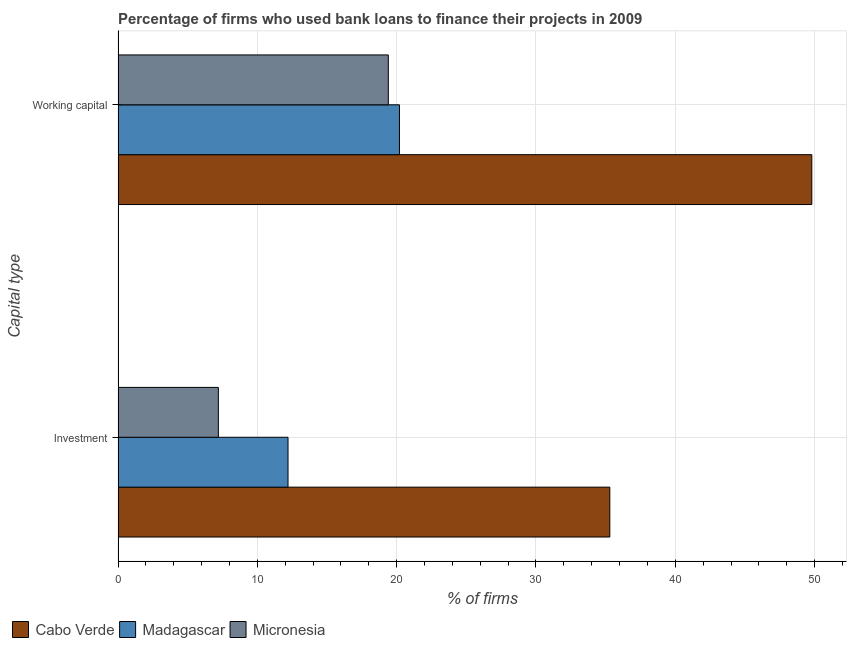How many different coloured bars are there?
Your response must be concise. 3. How many groups of bars are there?
Provide a succinct answer. 2. Are the number of bars per tick equal to the number of legend labels?
Your answer should be very brief. Yes. How many bars are there on the 1st tick from the top?
Ensure brevity in your answer.  3. How many bars are there on the 1st tick from the bottom?
Your answer should be compact. 3. What is the label of the 1st group of bars from the top?
Keep it short and to the point. Working capital. What is the percentage of firms using banks to finance working capital in Cabo Verde?
Your answer should be compact. 49.8. Across all countries, what is the maximum percentage of firms using banks to finance working capital?
Your answer should be compact. 49.8. Across all countries, what is the minimum percentage of firms using banks to finance working capital?
Provide a short and direct response. 19.4. In which country was the percentage of firms using banks to finance investment maximum?
Ensure brevity in your answer.  Cabo Verde. In which country was the percentage of firms using banks to finance working capital minimum?
Your response must be concise. Micronesia. What is the total percentage of firms using banks to finance working capital in the graph?
Your answer should be compact. 89.4. What is the difference between the percentage of firms using banks to finance investment in Cabo Verde and that in Madagascar?
Your response must be concise. 23.1. What is the difference between the percentage of firms using banks to finance investment in Cabo Verde and the percentage of firms using banks to finance working capital in Madagascar?
Offer a very short reply. 15.1. What is the average percentage of firms using banks to finance investment per country?
Offer a very short reply. 18.23. What is the ratio of the percentage of firms using banks to finance investment in Cabo Verde to that in Madagascar?
Give a very brief answer. 2.89. What does the 1st bar from the top in Investment represents?
Offer a very short reply. Micronesia. What does the 2nd bar from the bottom in Working capital represents?
Make the answer very short. Madagascar. How many bars are there?
Provide a succinct answer. 6. Are all the bars in the graph horizontal?
Keep it short and to the point. Yes. What is the difference between two consecutive major ticks on the X-axis?
Offer a terse response. 10. Are the values on the major ticks of X-axis written in scientific E-notation?
Your response must be concise. No. Does the graph contain any zero values?
Your answer should be compact. No. Where does the legend appear in the graph?
Give a very brief answer. Bottom left. What is the title of the graph?
Your answer should be compact. Percentage of firms who used bank loans to finance their projects in 2009. Does "Senegal" appear as one of the legend labels in the graph?
Your answer should be very brief. No. What is the label or title of the X-axis?
Your answer should be compact. % of firms. What is the label or title of the Y-axis?
Provide a short and direct response. Capital type. What is the % of firms of Cabo Verde in Investment?
Your response must be concise. 35.3. What is the % of firms in Madagascar in Investment?
Offer a very short reply. 12.2. What is the % of firms in Cabo Verde in Working capital?
Provide a short and direct response. 49.8. What is the % of firms in Madagascar in Working capital?
Provide a short and direct response. 20.2. Across all Capital type, what is the maximum % of firms in Cabo Verde?
Provide a short and direct response. 49.8. Across all Capital type, what is the maximum % of firms in Madagascar?
Give a very brief answer. 20.2. Across all Capital type, what is the maximum % of firms in Micronesia?
Provide a succinct answer. 19.4. Across all Capital type, what is the minimum % of firms of Cabo Verde?
Provide a short and direct response. 35.3. Across all Capital type, what is the minimum % of firms in Micronesia?
Make the answer very short. 7.2. What is the total % of firms in Cabo Verde in the graph?
Provide a short and direct response. 85.1. What is the total % of firms of Madagascar in the graph?
Make the answer very short. 32.4. What is the total % of firms of Micronesia in the graph?
Your answer should be compact. 26.6. What is the difference between the % of firms in Madagascar in Investment and that in Working capital?
Provide a short and direct response. -8. What is the difference between the % of firms of Micronesia in Investment and that in Working capital?
Ensure brevity in your answer.  -12.2. What is the difference between the % of firms of Cabo Verde in Investment and the % of firms of Madagascar in Working capital?
Your response must be concise. 15.1. What is the difference between the % of firms of Madagascar in Investment and the % of firms of Micronesia in Working capital?
Your answer should be very brief. -7.2. What is the average % of firms in Cabo Verde per Capital type?
Make the answer very short. 42.55. What is the average % of firms in Madagascar per Capital type?
Offer a very short reply. 16.2. What is the difference between the % of firms in Cabo Verde and % of firms in Madagascar in Investment?
Keep it short and to the point. 23.1. What is the difference between the % of firms of Cabo Verde and % of firms of Micronesia in Investment?
Your answer should be very brief. 28.1. What is the difference between the % of firms of Cabo Verde and % of firms of Madagascar in Working capital?
Offer a very short reply. 29.6. What is the difference between the % of firms in Cabo Verde and % of firms in Micronesia in Working capital?
Your answer should be very brief. 30.4. What is the difference between the % of firms of Madagascar and % of firms of Micronesia in Working capital?
Keep it short and to the point. 0.8. What is the ratio of the % of firms in Cabo Verde in Investment to that in Working capital?
Your response must be concise. 0.71. What is the ratio of the % of firms in Madagascar in Investment to that in Working capital?
Keep it short and to the point. 0.6. What is the ratio of the % of firms of Micronesia in Investment to that in Working capital?
Your response must be concise. 0.37. What is the difference between the highest and the second highest % of firms of Cabo Verde?
Offer a very short reply. 14.5. What is the difference between the highest and the second highest % of firms in Micronesia?
Offer a terse response. 12.2. What is the difference between the highest and the lowest % of firms of Cabo Verde?
Your answer should be very brief. 14.5. What is the difference between the highest and the lowest % of firms in Madagascar?
Your answer should be compact. 8. What is the difference between the highest and the lowest % of firms in Micronesia?
Provide a short and direct response. 12.2. 